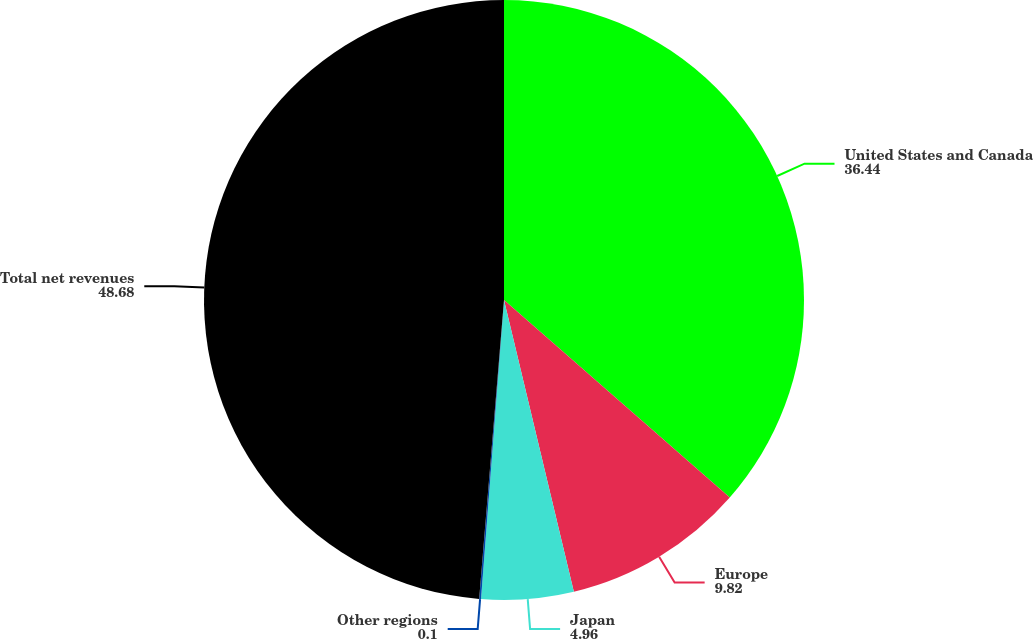Convert chart. <chart><loc_0><loc_0><loc_500><loc_500><pie_chart><fcel>United States and Canada<fcel>Europe<fcel>Japan<fcel>Other regions<fcel>Total net revenues<nl><fcel>36.44%<fcel>9.82%<fcel>4.96%<fcel>0.1%<fcel>48.68%<nl></chart> 